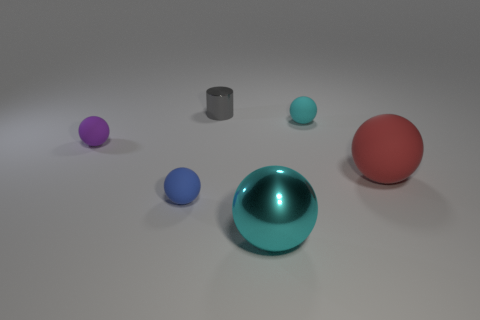Are there any other things that are the same material as the large red ball?
Provide a succinct answer. Yes. What is the small gray object that is on the left side of the metal object on the right side of the metallic object that is behind the red rubber sphere made of?
Keep it short and to the point. Metal. Is the color of the large metallic thing the same as the large matte object?
Your answer should be compact. No. Is there a rubber sphere of the same color as the large metallic sphere?
Offer a terse response. Yes. What is the shape of the gray thing that is the same size as the cyan matte thing?
Provide a succinct answer. Cylinder. Are there fewer blue rubber balls than big red shiny blocks?
Ensure brevity in your answer.  No. What number of purple matte things are the same size as the blue sphere?
Provide a short and direct response. 1. What is the shape of the tiny thing that is the same color as the large shiny sphere?
Offer a terse response. Sphere. What material is the large cyan sphere?
Provide a succinct answer. Metal. There is a cyan ball that is behind the red sphere; what size is it?
Offer a terse response. Small. 